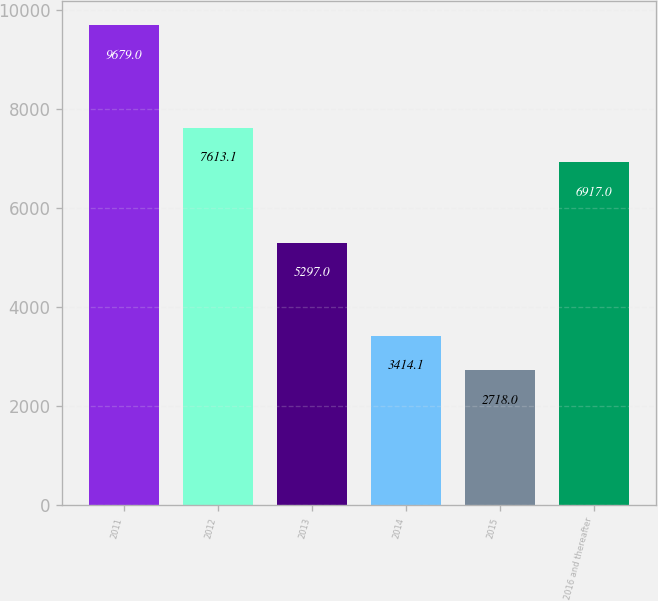Convert chart to OTSL. <chart><loc_0><loc_0><loc_500><loc_500><bar_chart><fcel>2011<fcel>2012<fcel>2013<fcel>2014<fcel>2015<fcel>2016 and thereafter<nl><fcel>9679<fcel>7613.1<fcel>5297<fcel>3414.1<fcel>2718<fcel>6917<nl></chart> 